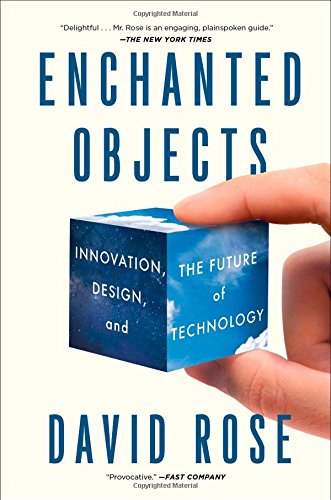Does this book discuss specific enchanted objects? Yes, 'Enchanted Objects' discusses various objects that incorporate technology to enhance functionality and user experience, such as umbrellas that can predict rain or doorbells that inform you of visitors' identities. What might be the implications of these technologies on our daily lives? The implications are vast and transformative. These technologies could lead to increased convenience, personalized interactions, and more intuitive use of objects, reshaping our living environments and social habits. 